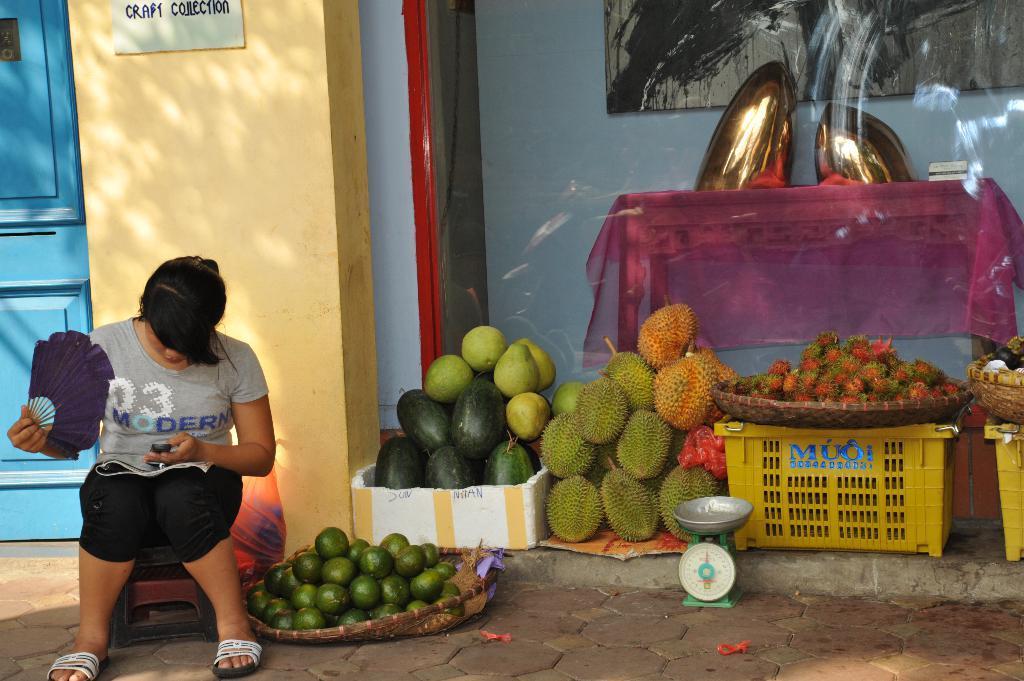Please provide a concise description of this image. In this image, we can see some fruits. There is a basket and weighing scale in the bottom right of the image. There is a person in the bottom left of the image holding a hand fan and sitting on the stool in front of the wall. There is a door on the left side of the image. 